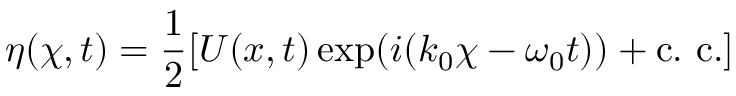Convert formula to latex. <formula><loc_0><loc_0><loc_500><loc_500>\eta ( \chi , t ) = \frac { 1 } { 2 } [ U ( x , t ) \exp ( i ( k _ { 0 } \chi - \omega _ { 0 } t ) ) + { c . c . } ]</formula> 